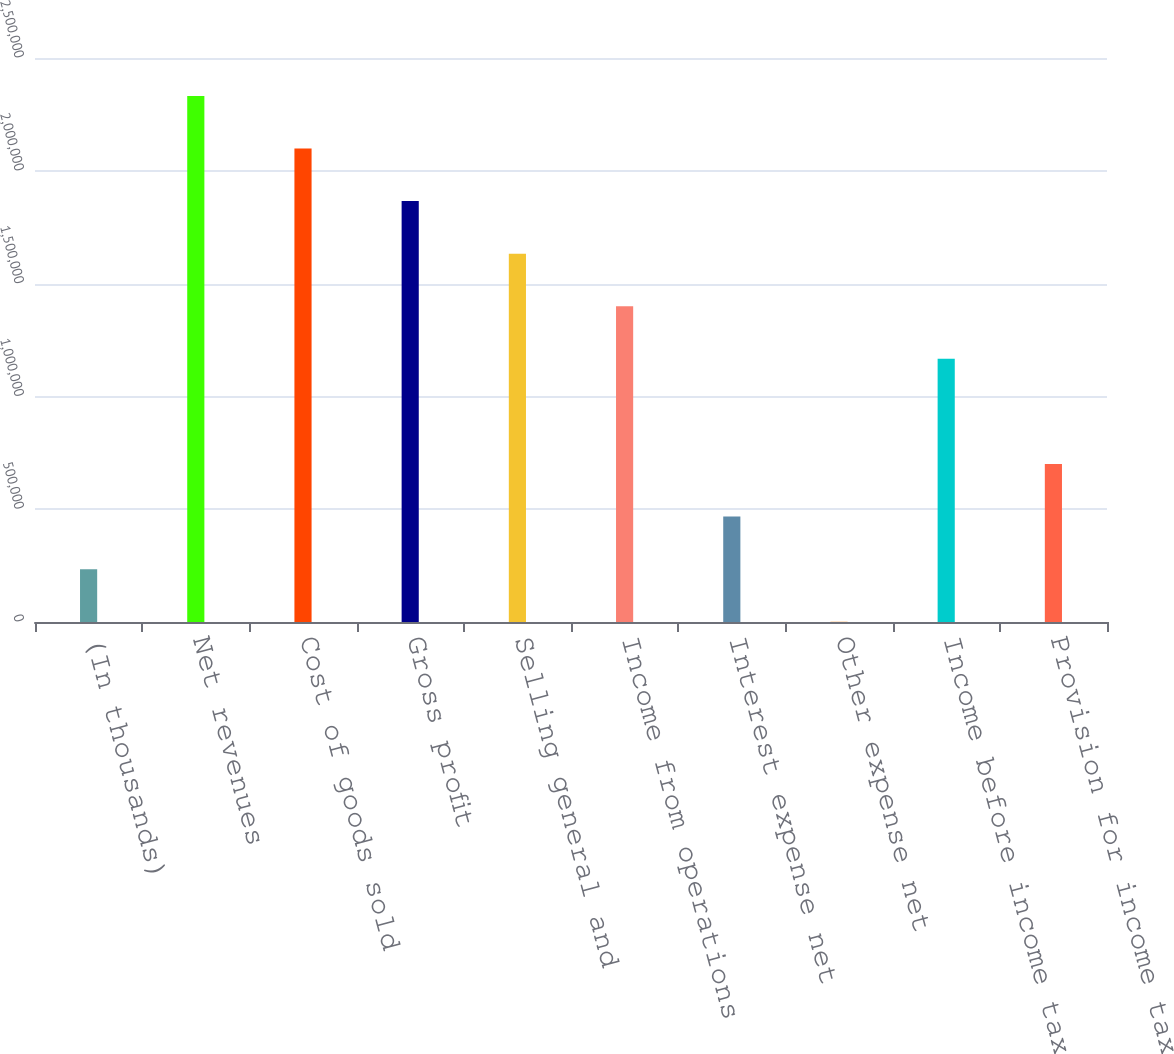<chart> <loc_0><loc_0><loc_500><loc_500><bar_chart><fcel>(In thousands)<fcel>Net revenues<fcel>Cost of goods sold<fcel>Gross profit<fcel>Selling general and<fcel>Income from operations<fcel>Interest expense net<fcel>Other expense net<fcel>Income before income taxes<fcel>Provision for income taxes<nl><fcel>234260<fcel>2.33205e+06<fcel>2.09896e+06<fcel>1.86588e+06<fcel>1.63279e+06<fcel>1.3997e+06<fcel>467348<fcel>1172<fcel>1.16661e+06<fcel>700436<nl></chart> 